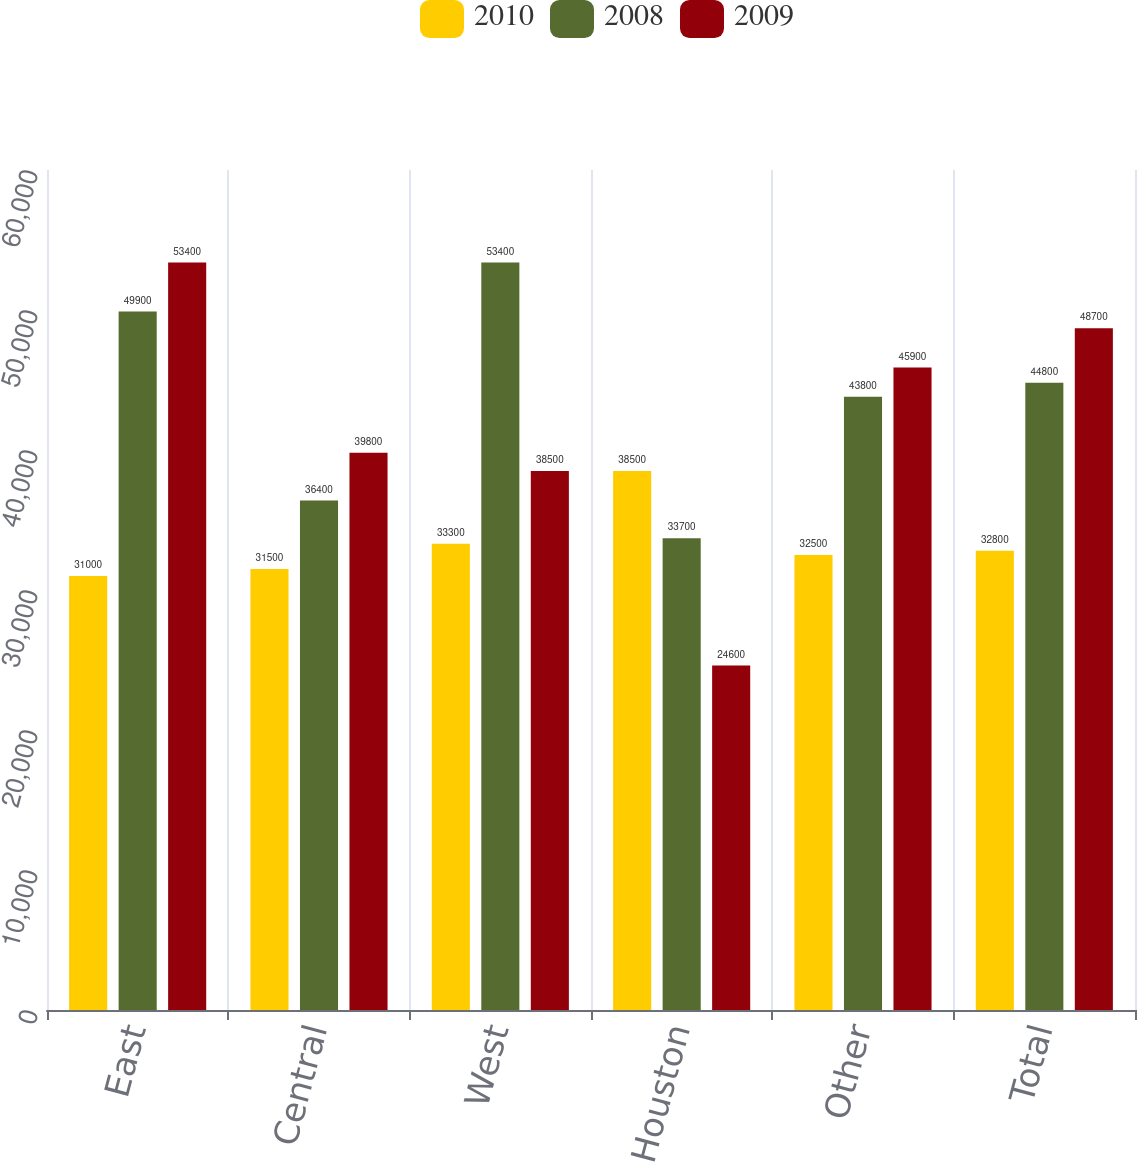Convert chart to OTSL. <chart><loc_0><loc_0><loc_500><loc_500><stacked_bar_chart><ecel><fcel>East<fcel>Central<fcel>West<fcel>Houston<fcel>Other<fcel>Total<nl><fcel>2010<fcel>31000<fcel>31500<fcel>33300<fcel>38500<fcel>32500<fcel>32800<nl><fcel>2008<fcel>49900<fcel>36400<fcel>53400<fcel>33700<fcel>43800<fcel>44800<nl><fcel>2009<fcel>53400<fcel>39800<fcel>38500<fcel>24600<fcel>45900<fcel>48700<nl></chart> 